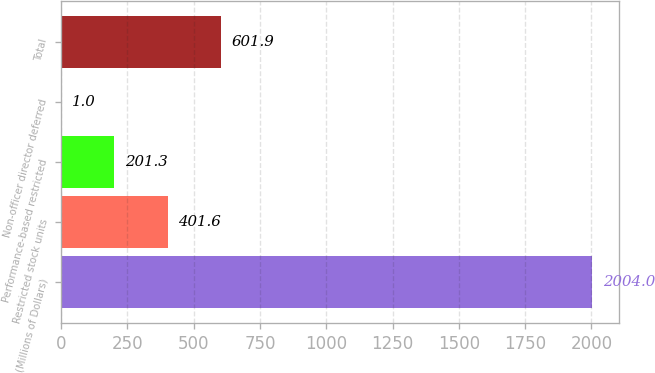Convert chart to OTSL. <chart><loc_0><loc_0><loc_500><loc_500><bar_chart><fcel>(Millions of Dollars)<fcel>Restricted stock units<fcel>Performance-based restricted<fcel>Non-officer director deferred<fcel>Total<nl><fcel>2004<fcel>401.6<fcel>201.3<fcel>1<fcel>601.9<nl></chart> 